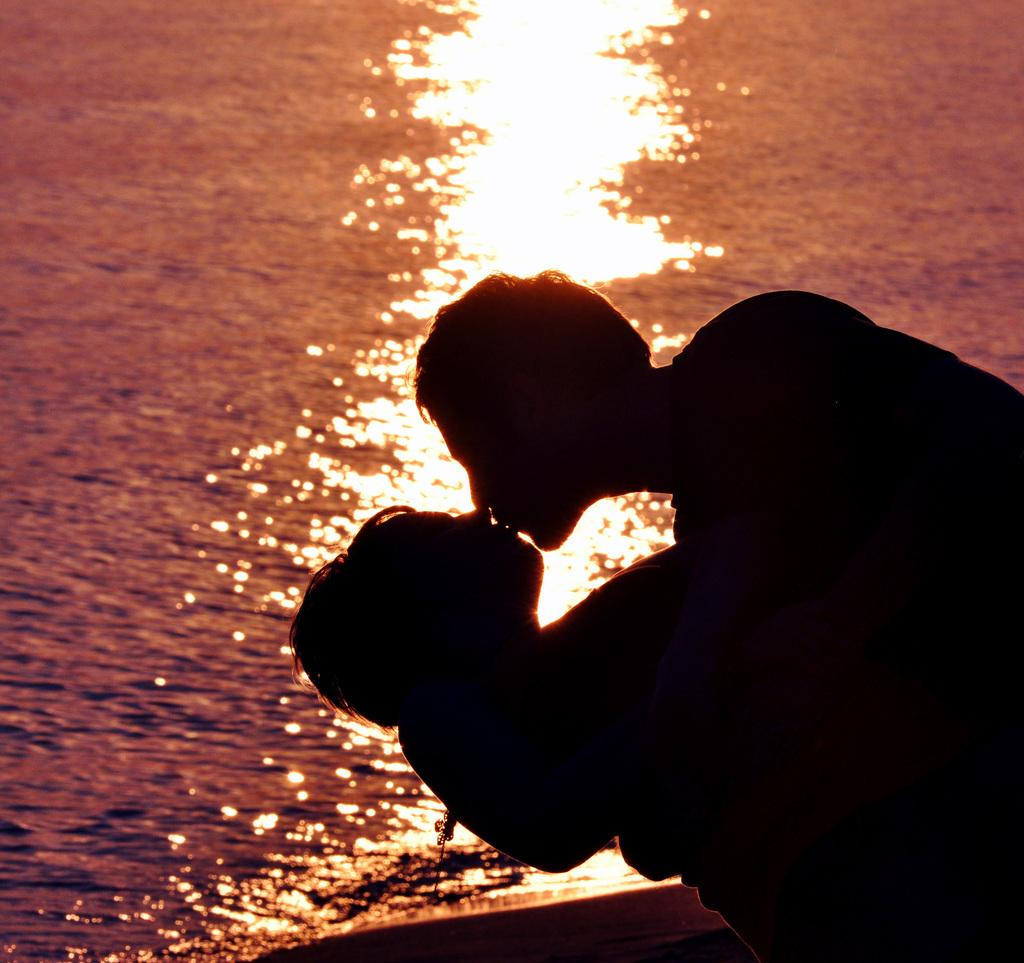Who is present in the image? There is a person and a woman in the image. What are the person and woman doing in the image? The person and woman are kissing in the image. What type of picture is the image? The image is a night vision picture. What can be seen in the background of the image? There is water visible in the background of the image. What type of pie is being served on the chessboard in the image? There is no chessboard or pie present in the image. What is the woman using to whip the water in the background? There is no whip or whipping action in the image; the woman is kissing the person, and there is water visible in the background. 